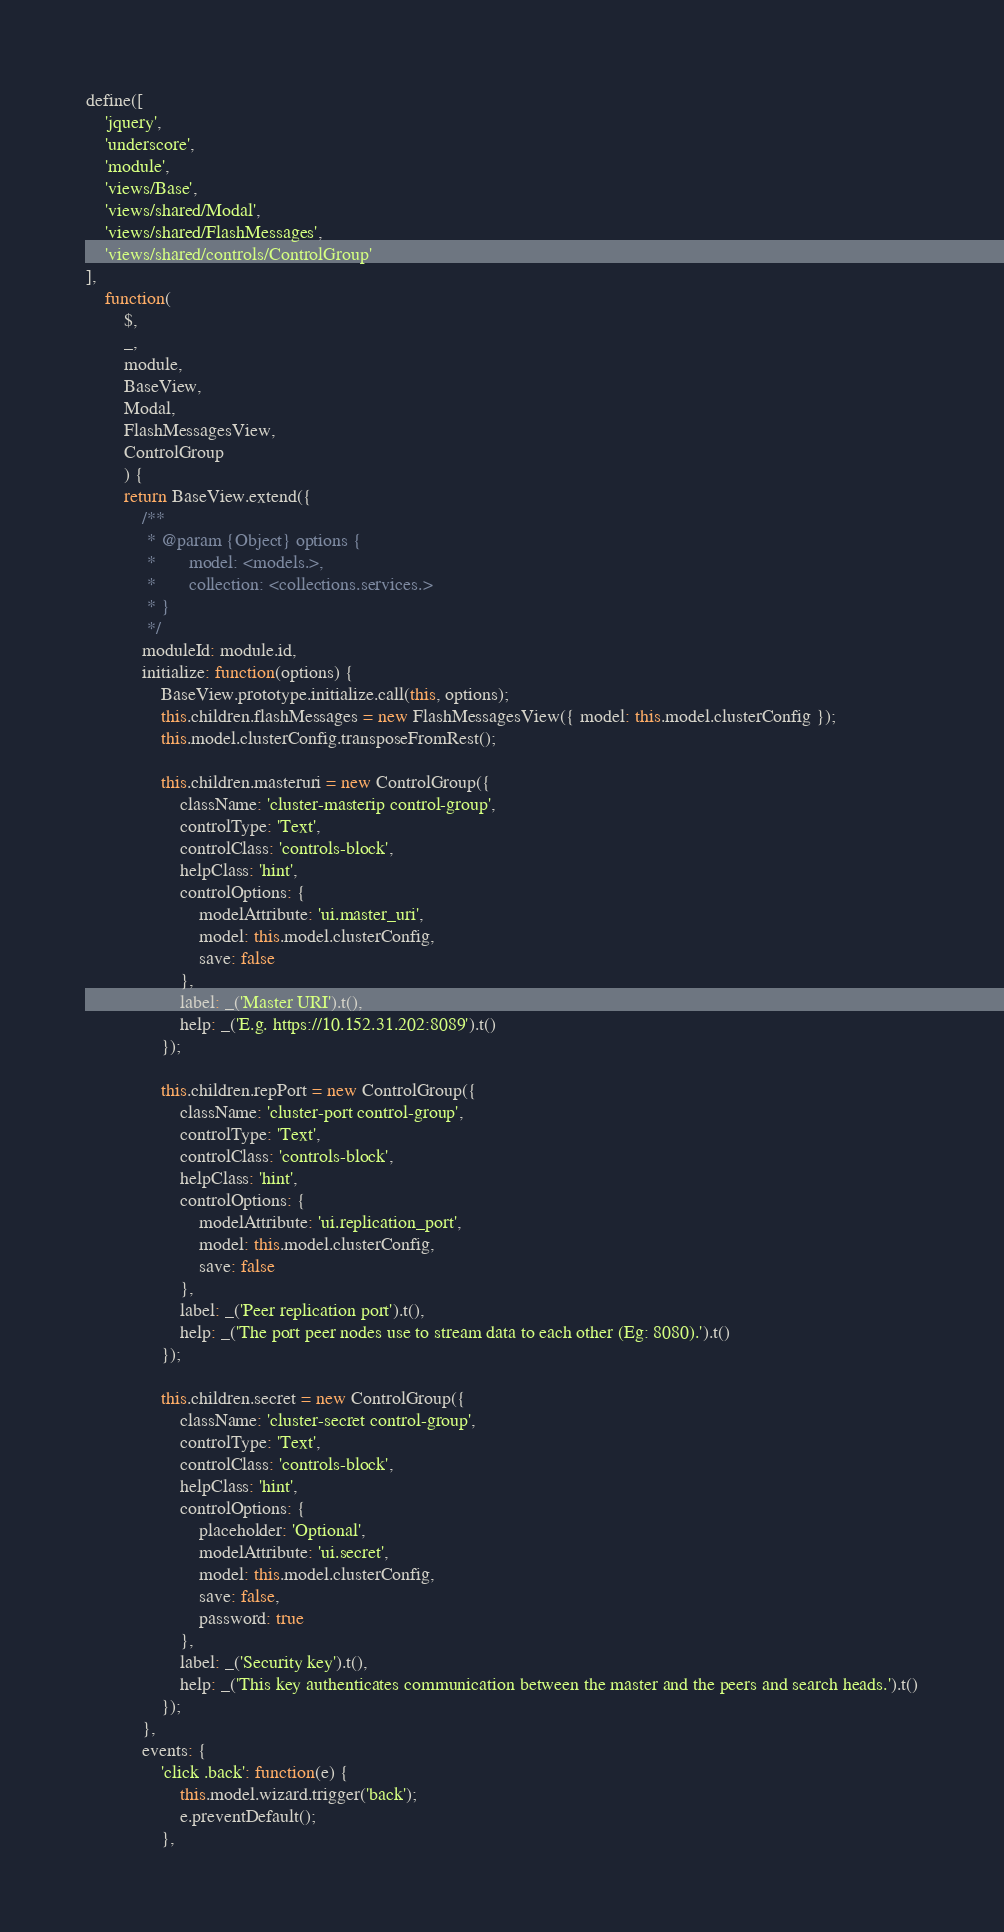Convert code to text. <code><loc_0><loc_0><loc_500><loc_500><_JavaScript_>define([
    'jquery',
    'underscore',
    'module',
    'views/Base',
    'views/shared/Modal',
    'views/shared/FlashMessages',
    'views/shared/controls/ControlGroup'
],
    function(
        $,
        _,
        module,
        BaseView,
        Modal,
        FlashMessagesView,
        ControlGroup
        ) {
        return BaseView.extend({
            /**
             * @param {Object} options {
             *       model: <models.>,
             *       collection: <collections.services.>
             * }
             */
            moduleId: module.id,
            initialize: function(options) {
                BaseView.prototype.initialize.call(this, options);
                this.children.flashMessages = new FlashMessagesView({ model: this.model.clusterConfig });
                this.model.clusterConfig.transposeFromRest();

                this.children.masteruri = new ControlGroup({
                    className: 'cluster-masterip control-group',
                    controlType: 'Text',
                    controlClass: 'controls-block',
                    helpClass: 'hint',
                    controlOptions: {
                        modelAttribute: 'ui.master_uri',
                        model: this.model.clusterConfig,
                        save: false
                    },
                    label: _('Master URI').t(),
                    help: _('E.g. https://10.152.31.202:8089').t()
                });

                this.children.repPort = new ControlGroup({
                    className: 'cluster-port control-group',
                    controlType: 'Text',
                    controlClass: 'controls-block',
                    helpClass: 'hint',
                    controlOptions: {
                        modelAttribute: 'ui.replication_port',
                        model: this.model.clusterConfig,
                        save: false
                    },
                    label: _('Peer replication port').t(),
                    help: _('The port peer nodes use to stream data to each other (Eg: 8080).').t()
                });

                this.children.secret = new ControlGroup({
                    className: 'cluster-secret control-group',
                    controlType: 'Text',
                    controlClass: 'controls-block',
                    helpClass: 'hint',
                    controlOptions: {
                        placeholder: 'Optional',
                        modelAttribute: 'ui.secret',
                        model: this.model.clusterConfig,
                        save: false,
                        password: true
                    },
                    label: _('Security key').t(),
                    help: _('This key authenticates communication between the master and the peers and search heads.').t()
                });
            },
            events: {
                'click .back': function(e) {
                    this.model.wizard.trigger('back');
                    e.preventDefault();
                },</code> 